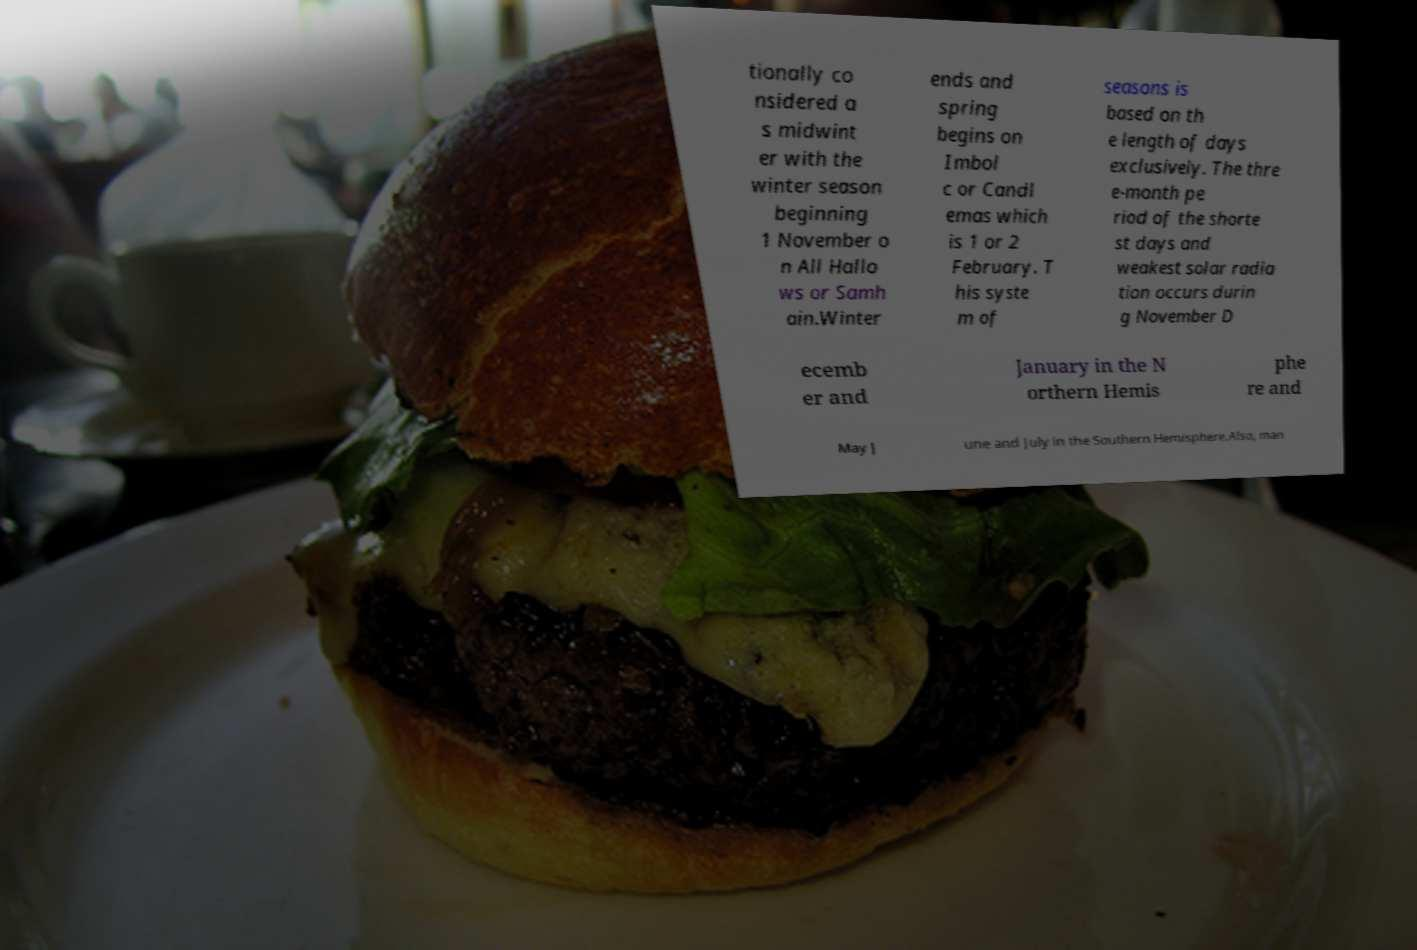Could you assist in decoding the text presented in this image and type it out clearly? tionally co nsidered a s midwint er with the winter season beginning 1 November o n All Hallo ws or Samh ain.Winter ends and spring begins on Imbol c or Candl emas which is 1 or 2 February. T his syste m of seasons is based on th e length of days exclusively. The thre e-month pe riod of the shorte st days and weakest solar radia tion occurs durin g November D ecemb er and January in the N orthern Hemis phe re and May J une and July in the Southern Hemisphere.Also, man 